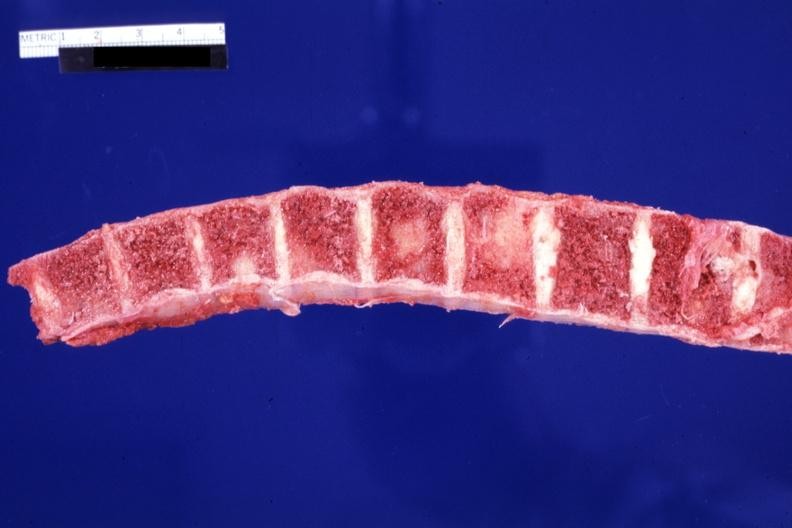s nipples present?
Answer the question using a single word or phrase. No 